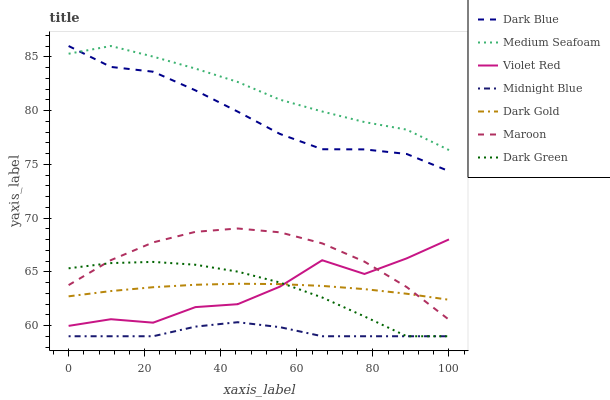Does Midnight Blue have the minimum area under the curve?
Answer yes or no. Yes. Does Medium Seafoam have the maximum area under the curve?
Answer yes or no. Yes. Does Dark Gold have the minimum area under the curve?
Answer yes or no. No. Does Dark Gold have the maximum area under the curve?
Answer yes or no. No. Is Dark Gold the smoothest?
Answer yes or no. Yes. Is Violet Red the roughest?
Answer yes or no. Yes. Is Midnight Blue the smoothest?
Answer yes or no. No. Is Midnight Blue the roughest?
Answer yes or no. No. Does Midnight Blue have the lowest value?
Answer yes or no. Yes. Does Dark Gold have the lowest value?
Answer yes or no. No. Does Medium Seafoam have the highest value?
Answer yes or no. Yes. Does Dark Gold have the highest value?
Answer yes or no. No. Is Dark Gold less than Dark Blue?
Answer yes or no. Yes. Is Violet Red greater than Midnight Blue?
Answer yes or no. Yes. Does Maroon intersect Dark Gold?
Answer yes or no. Yes. Is Maroon less than Dark Gold?
Answer yes or no. No. Is Maroon greater than Dark Gold?
Answer yes or no. No. Does Dark Gold intersect Dark Blue?
Answer yes or no. No. 